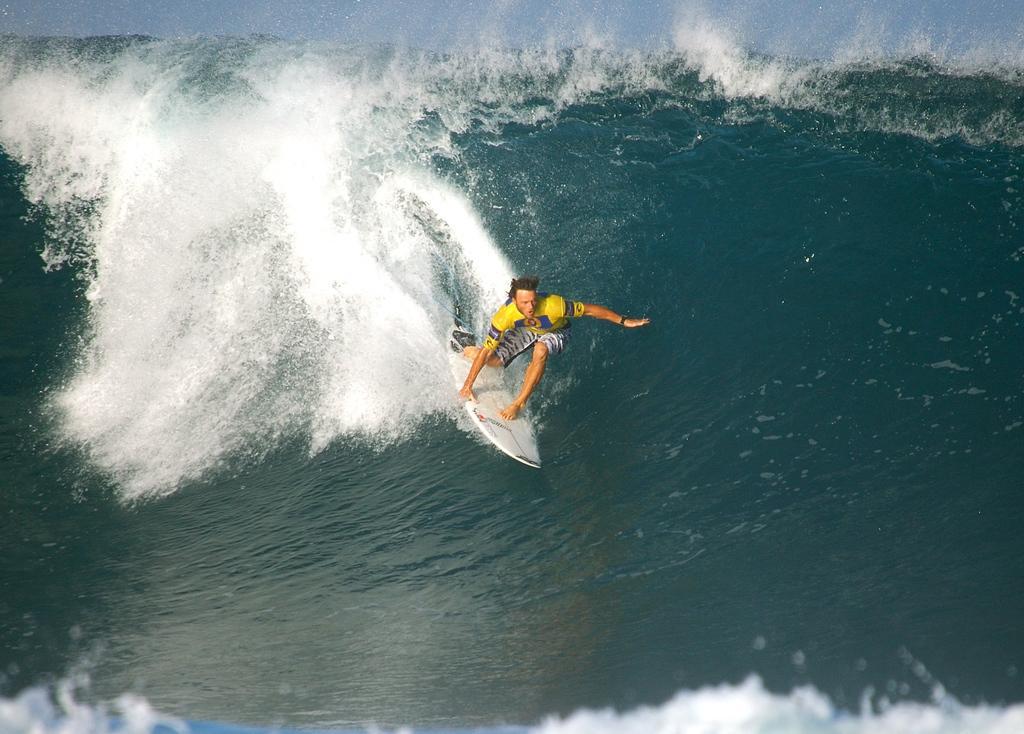Can you describe this image briefly? In this image, we can see a person surfing in the water. We can also see the sky. 